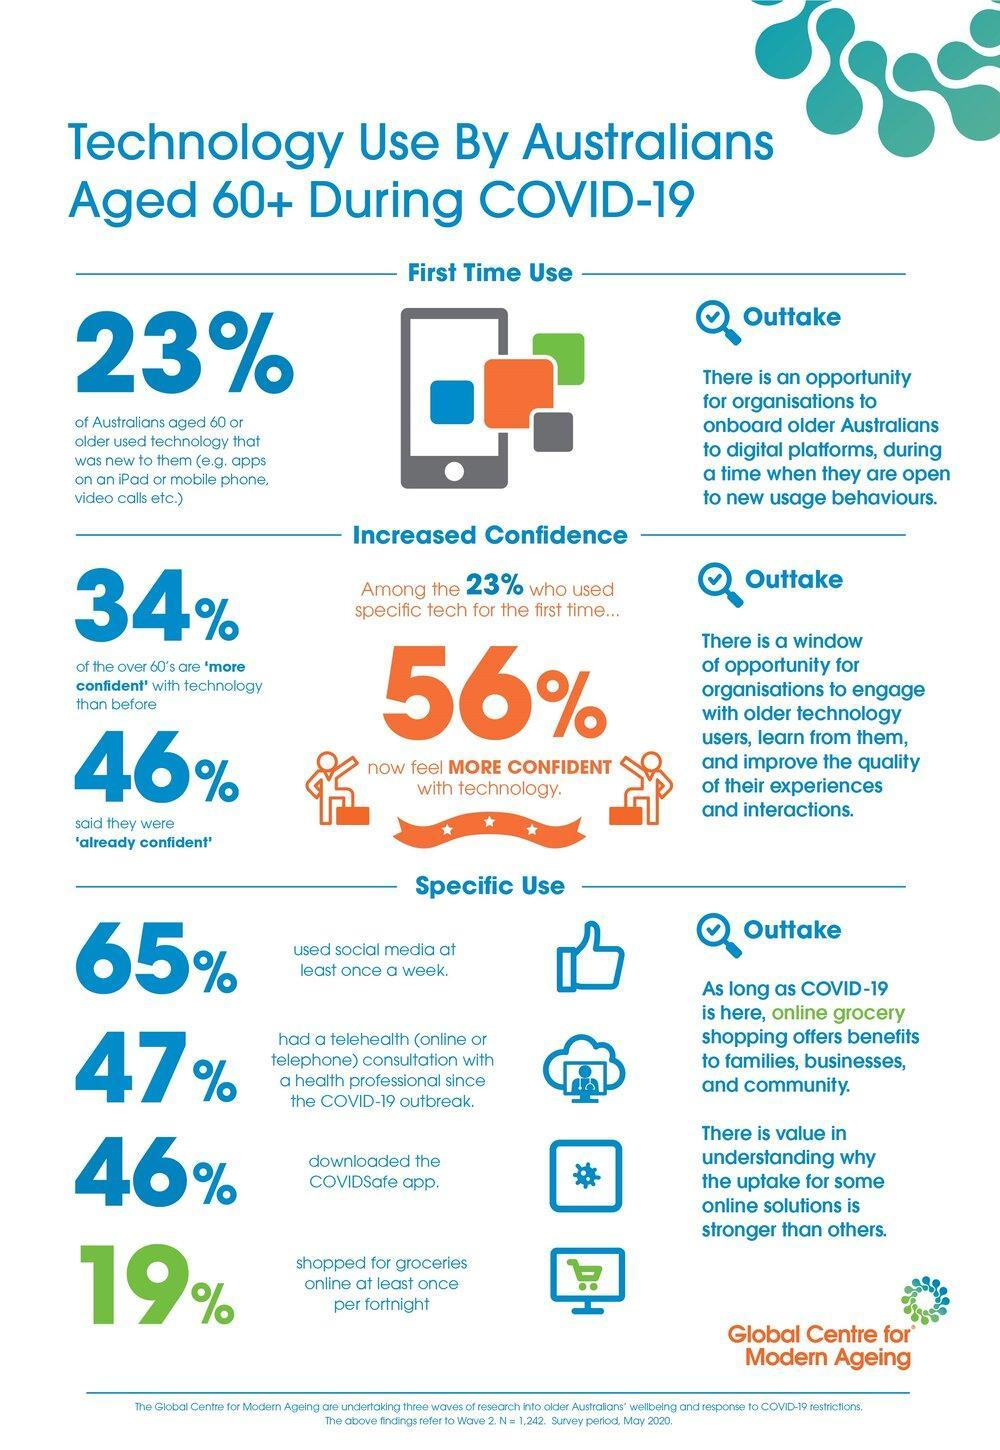What percent of senior citizens shopped for groceries once in two weeks?
Answer the question with a short phrase. 19% What percent of people over 60 are less confident with technology? 66% What percent of senior citizens use newer technology? 23% What percent used Instagram, Facebook or Twitter at least one time during a week? 65% 